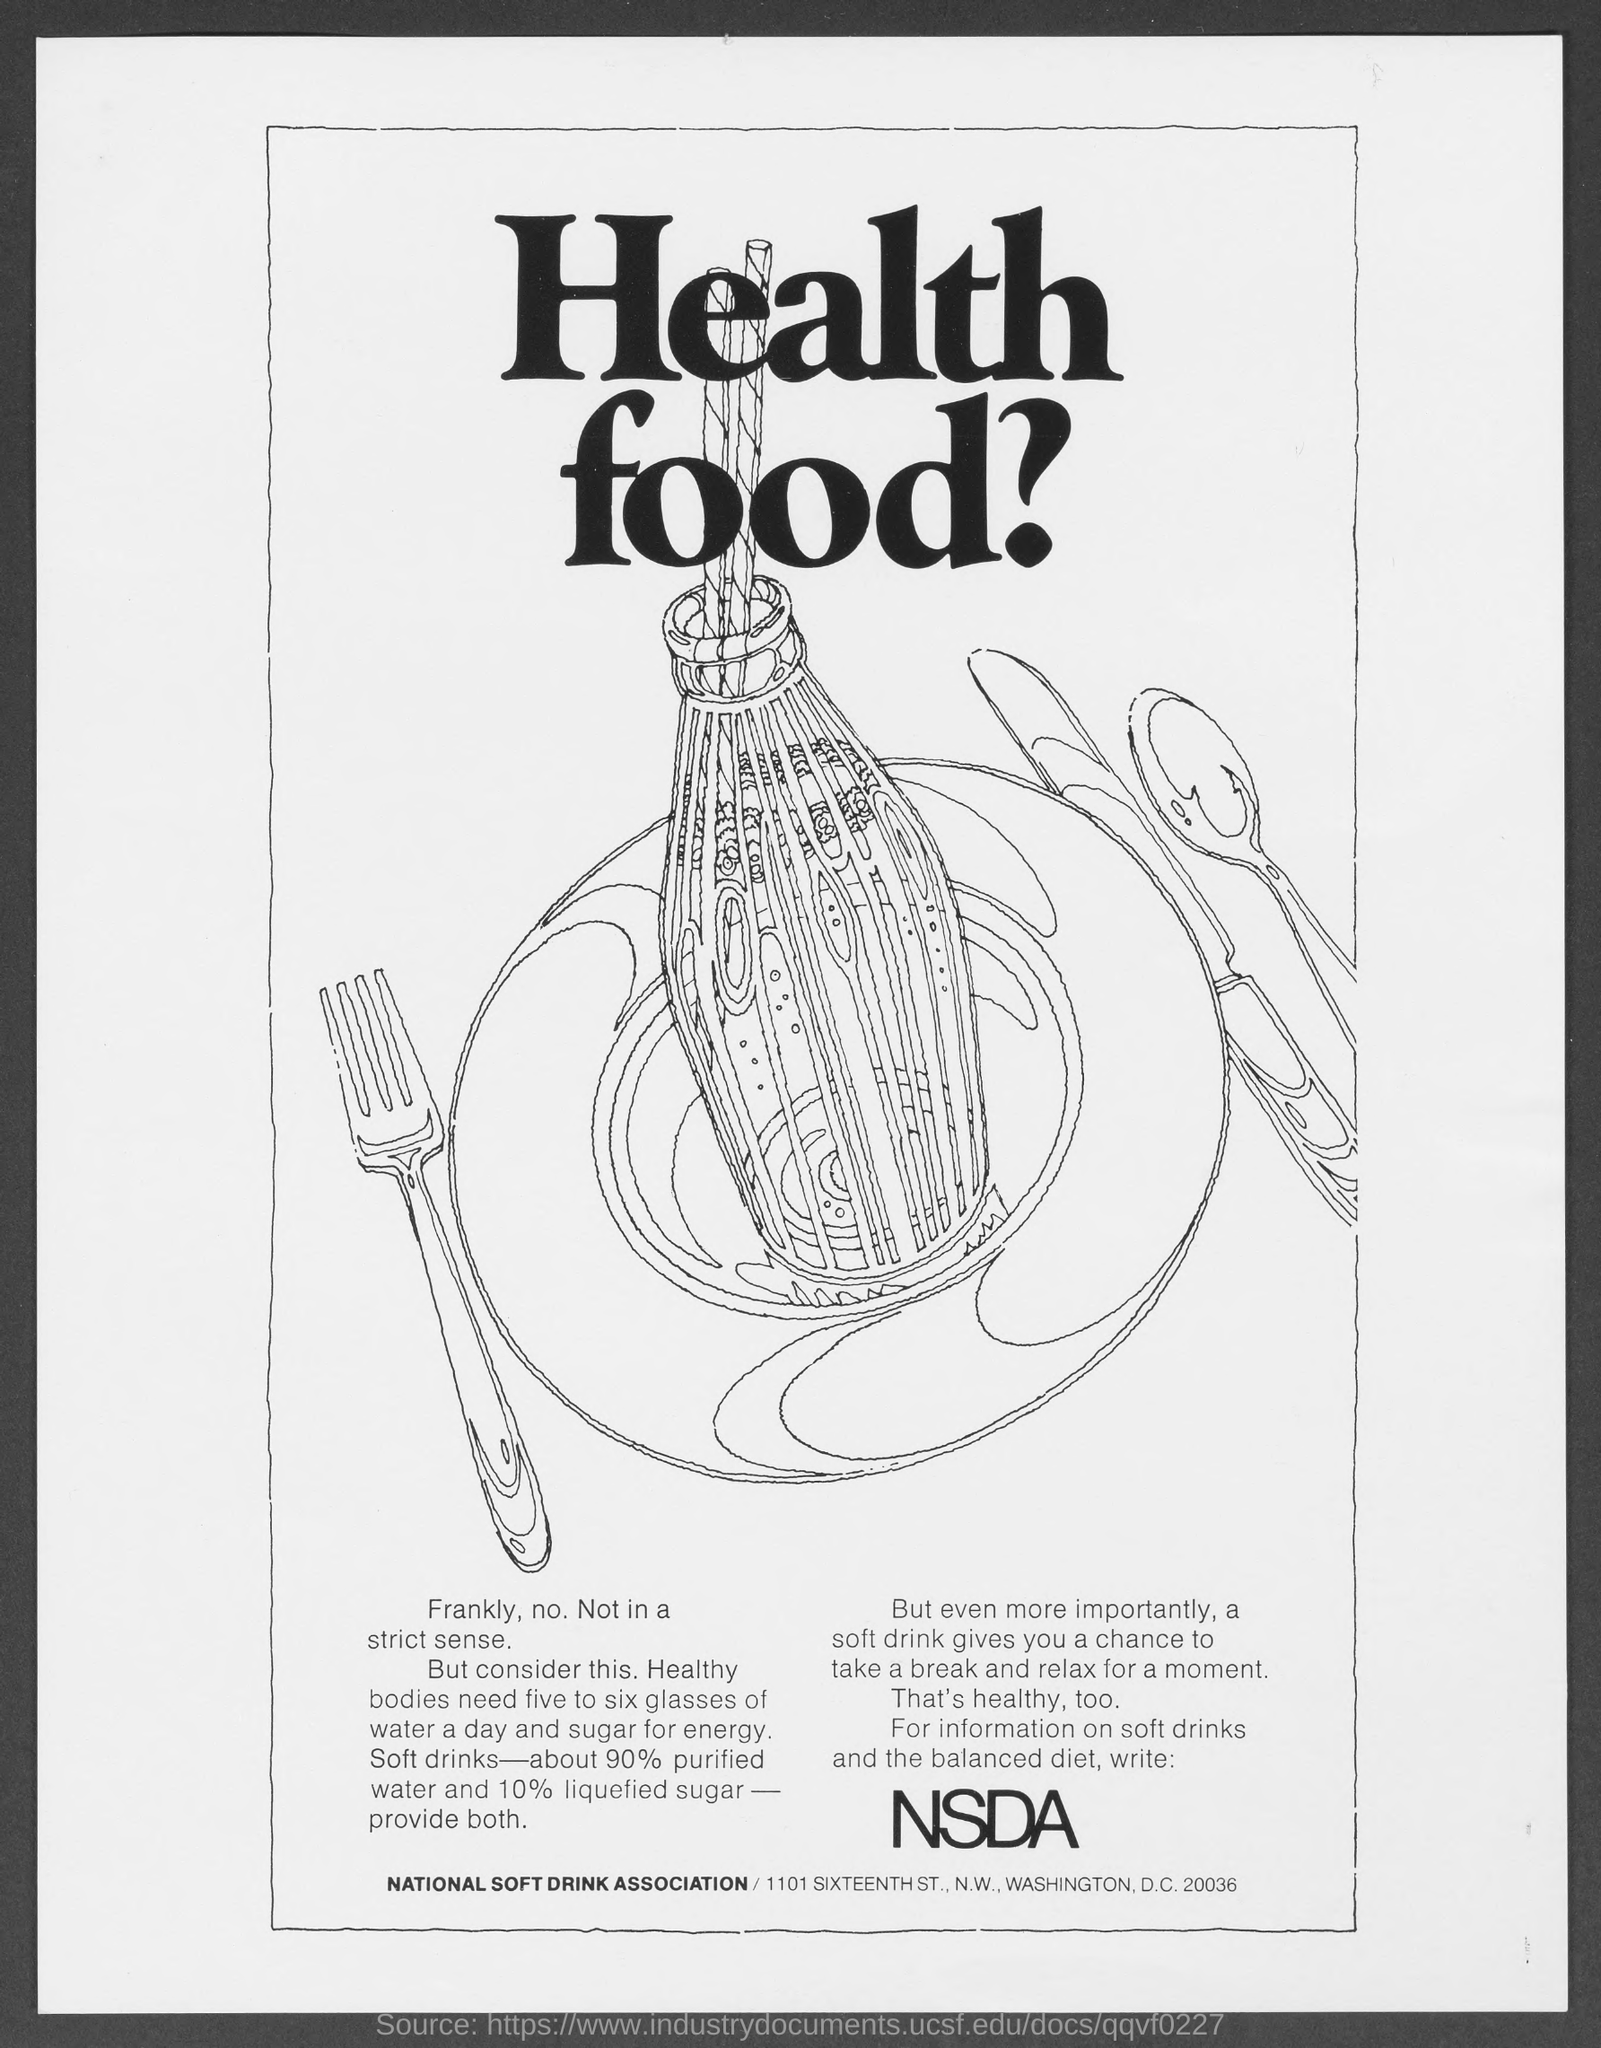What is the heading of the Document?
Your answer should be very brief. Health food?. What is the word in large font in the text under the picture?
Make the answer very short. NSDA. How many glasses of water do healthy bodies need a day?
Give a very brief answer. Five to six glasses of water. What is the zip code at the bottom of the document?
Offer a terse response. 20036. What is the percentage of liquefied sugar in Soft drinks?
Your answer should be compact. 10%. What is the percentage of purified water in Soft drinks?
Your answer should be very brief. 90%. 